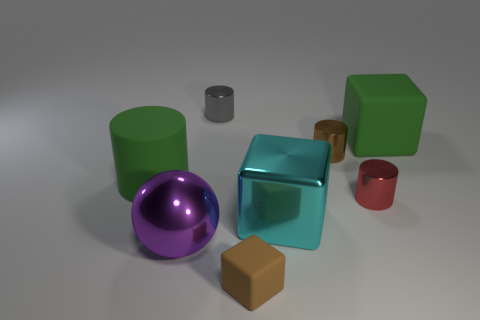Is the matte cylinder the same color as the large matte cube?
Your answer should be compact. Yes. How many other things are there of the same shape as the large cyan thing?
Make the answer very short. 2. Is the number of brown matte cubes to the left of the brown cylinder greater than the number of green matte cylinders to the left of the big shiny cube?
Provide a succinct answer. No. There is a block behind the brown metallic cylinder; is it the same size as the green object left of the large cyan metallic block?
Give a very brief answer. Yes. What is the shape of the purple thing?
Give a very brief answer. Sphere. There is a object that is the same color as the matte cylinder; what is its size?
Your response must be concise. Large. What color is the large thing that is the same material as the large purple ball?
Provide a succinct answer. Cyan. Are the green cylinder and the tiny brown object in front of the cyan cube made of the same material?
Your response must be concise. Yes. The big metallic block is what color?
Provide a short and direct response. Cyan. What size is the cyan thing that is made of the same material as the small brown cylinder?
Make the answer very short. Large. 